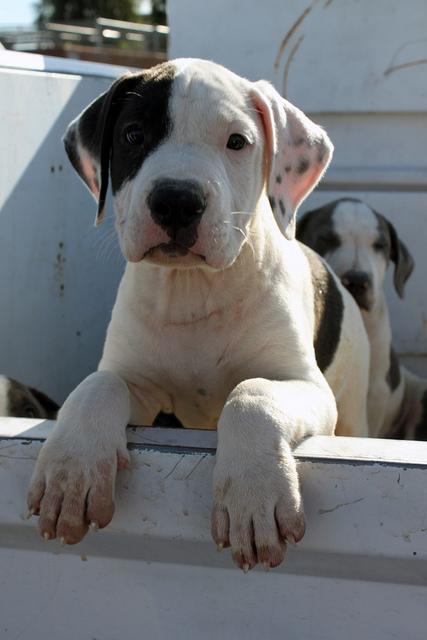How many dogs are in the picture?
Give a very brief answer. 2. 